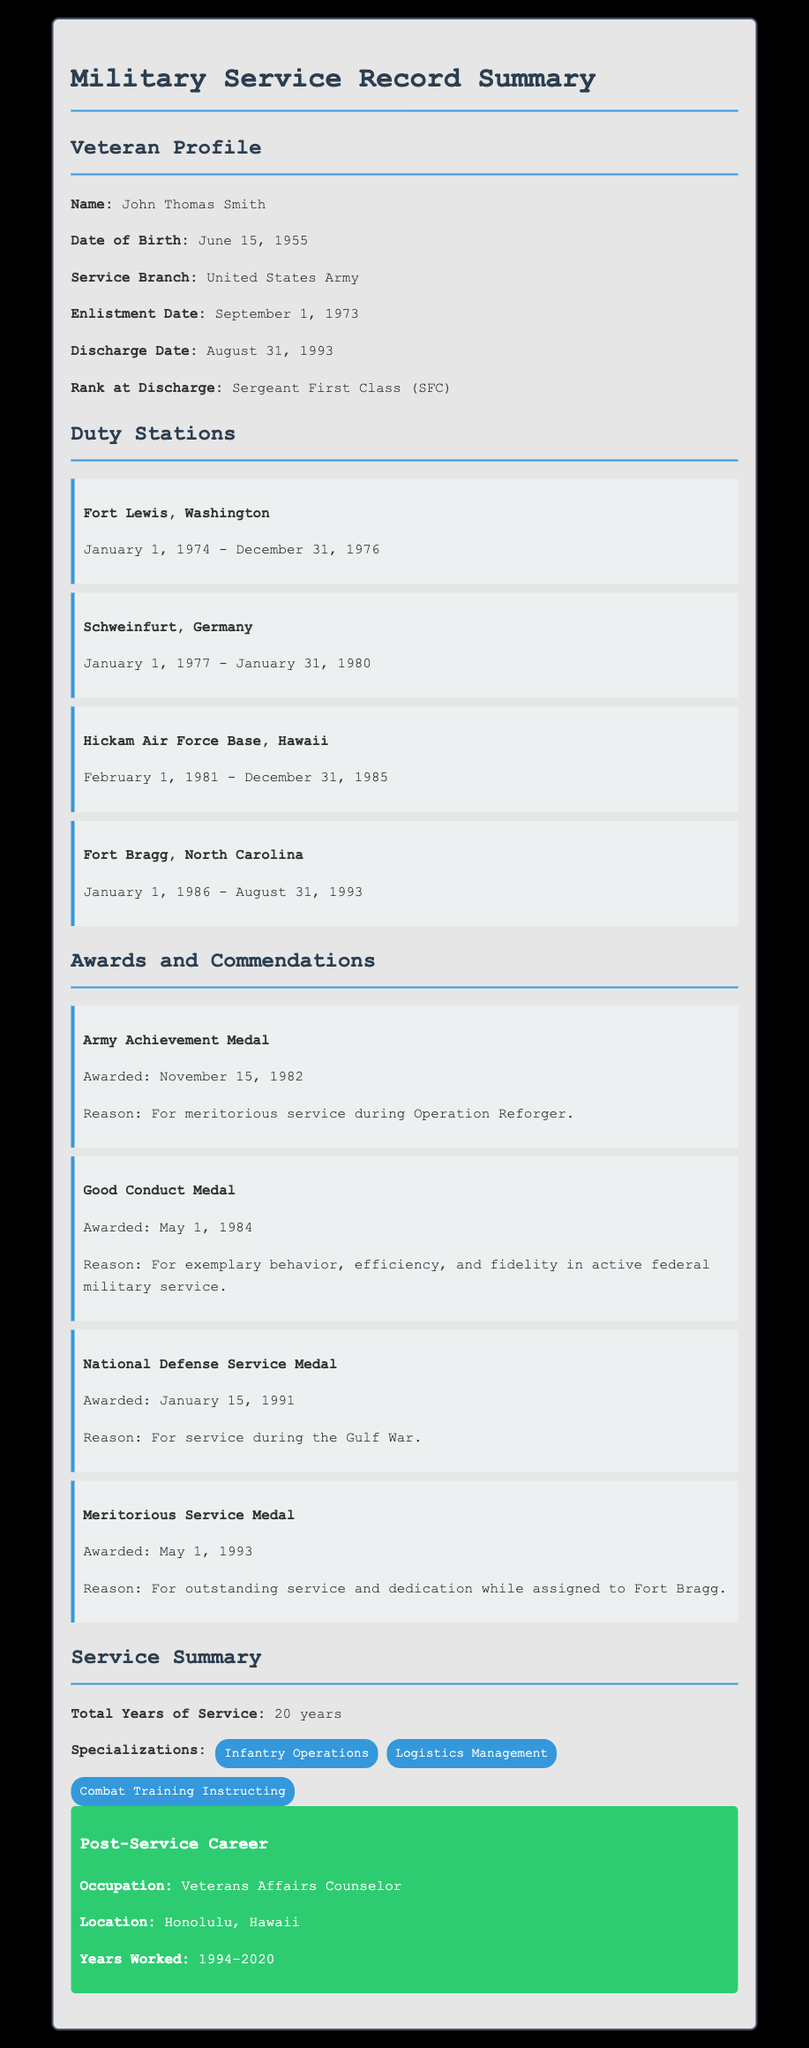What is the name of the veteran? The name of the veteran is listed at the beginning of the document under the Veteran Profile section.
Answer: John Thomas Smith When did the veteran enlist? The enlistment date is provided under the Veteran Profile section of the document.
Answer: September 1, 1973 What was the rank at discharge? The rank at discharge is clearly stated in the Veteran Profile section.
Answer: Sergeant First Class (SFC) How many duty stations did the veteran have? The number of duty stations can be counted in the Duty Stations section of the document.
Answer: Four Which award was given on May 1, 1984? This date can be found in the Awards and Commendations section, listing the award and its date.
Answer: Good Conduct Medal What is the total years of service? The total years of service is summarized in the Service Summary section of the document.
Answer: 20 years Where was the veteran stationed from February 1, 1981 to December 31, 1985? This information is found in the Duty Stations section, which lists each station and its dates.
Answer: Hickam Air Force Base, Hawaii What was the occupation post-service? The occupation after service is listed in the Post-Service Career section of the document.
Answer: Veterans Affairs Counselor What medal was awarded for service during the Gulf War? The award for service during the Gulf War is specified in the Awards and Commendations section.
Answer: National Defense Service Medal 